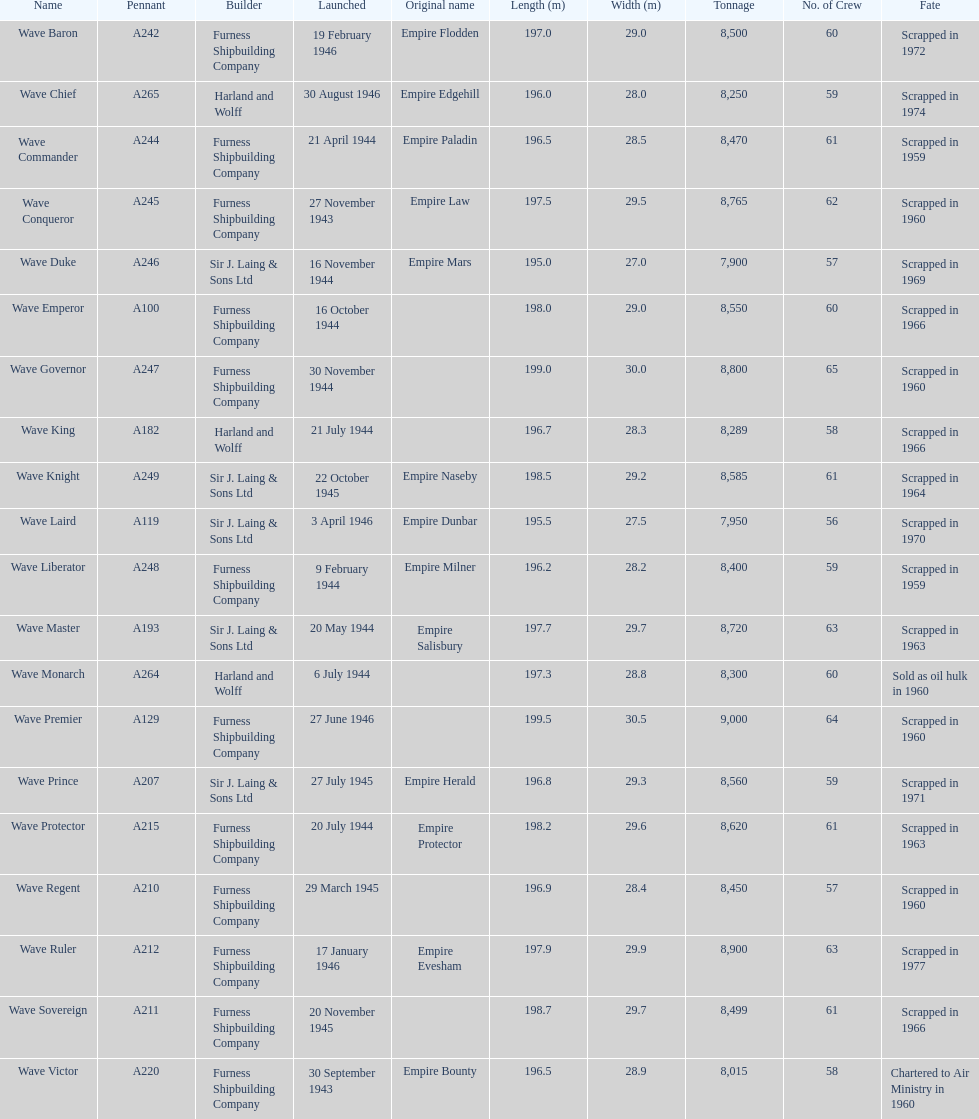How many ships were deployed in the year 1944? 9. 